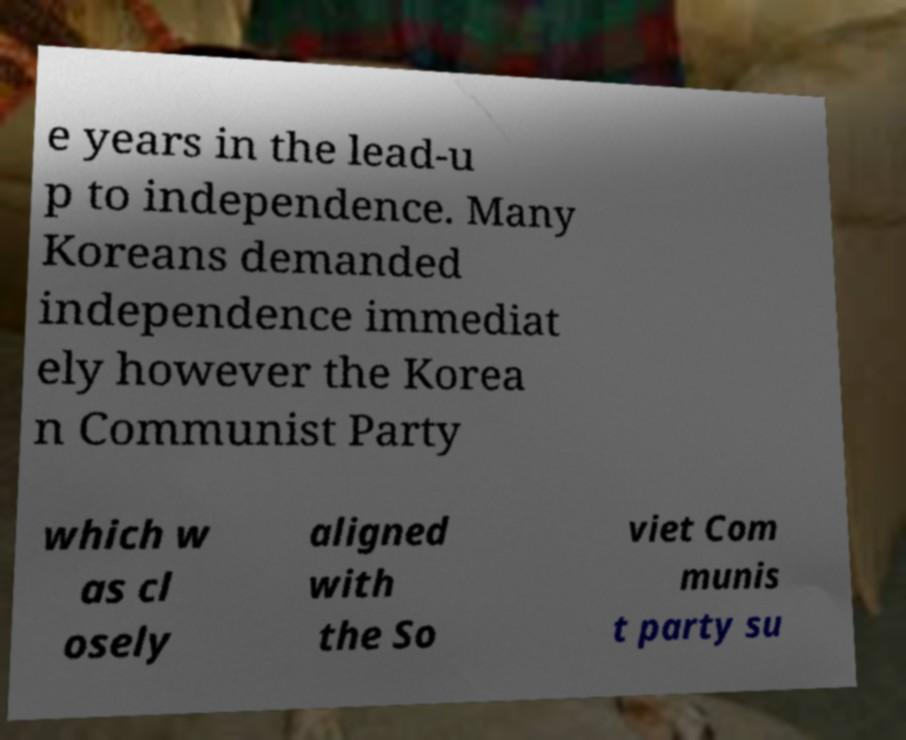Could you assist in decoding the text presented in this image and type it out clearly? e years in the lead-u p to independence. Many Koreans demanded independence immediat ely however the Korea n Communist Party which w as cl osely aligned with the So viet Com munis t party su 